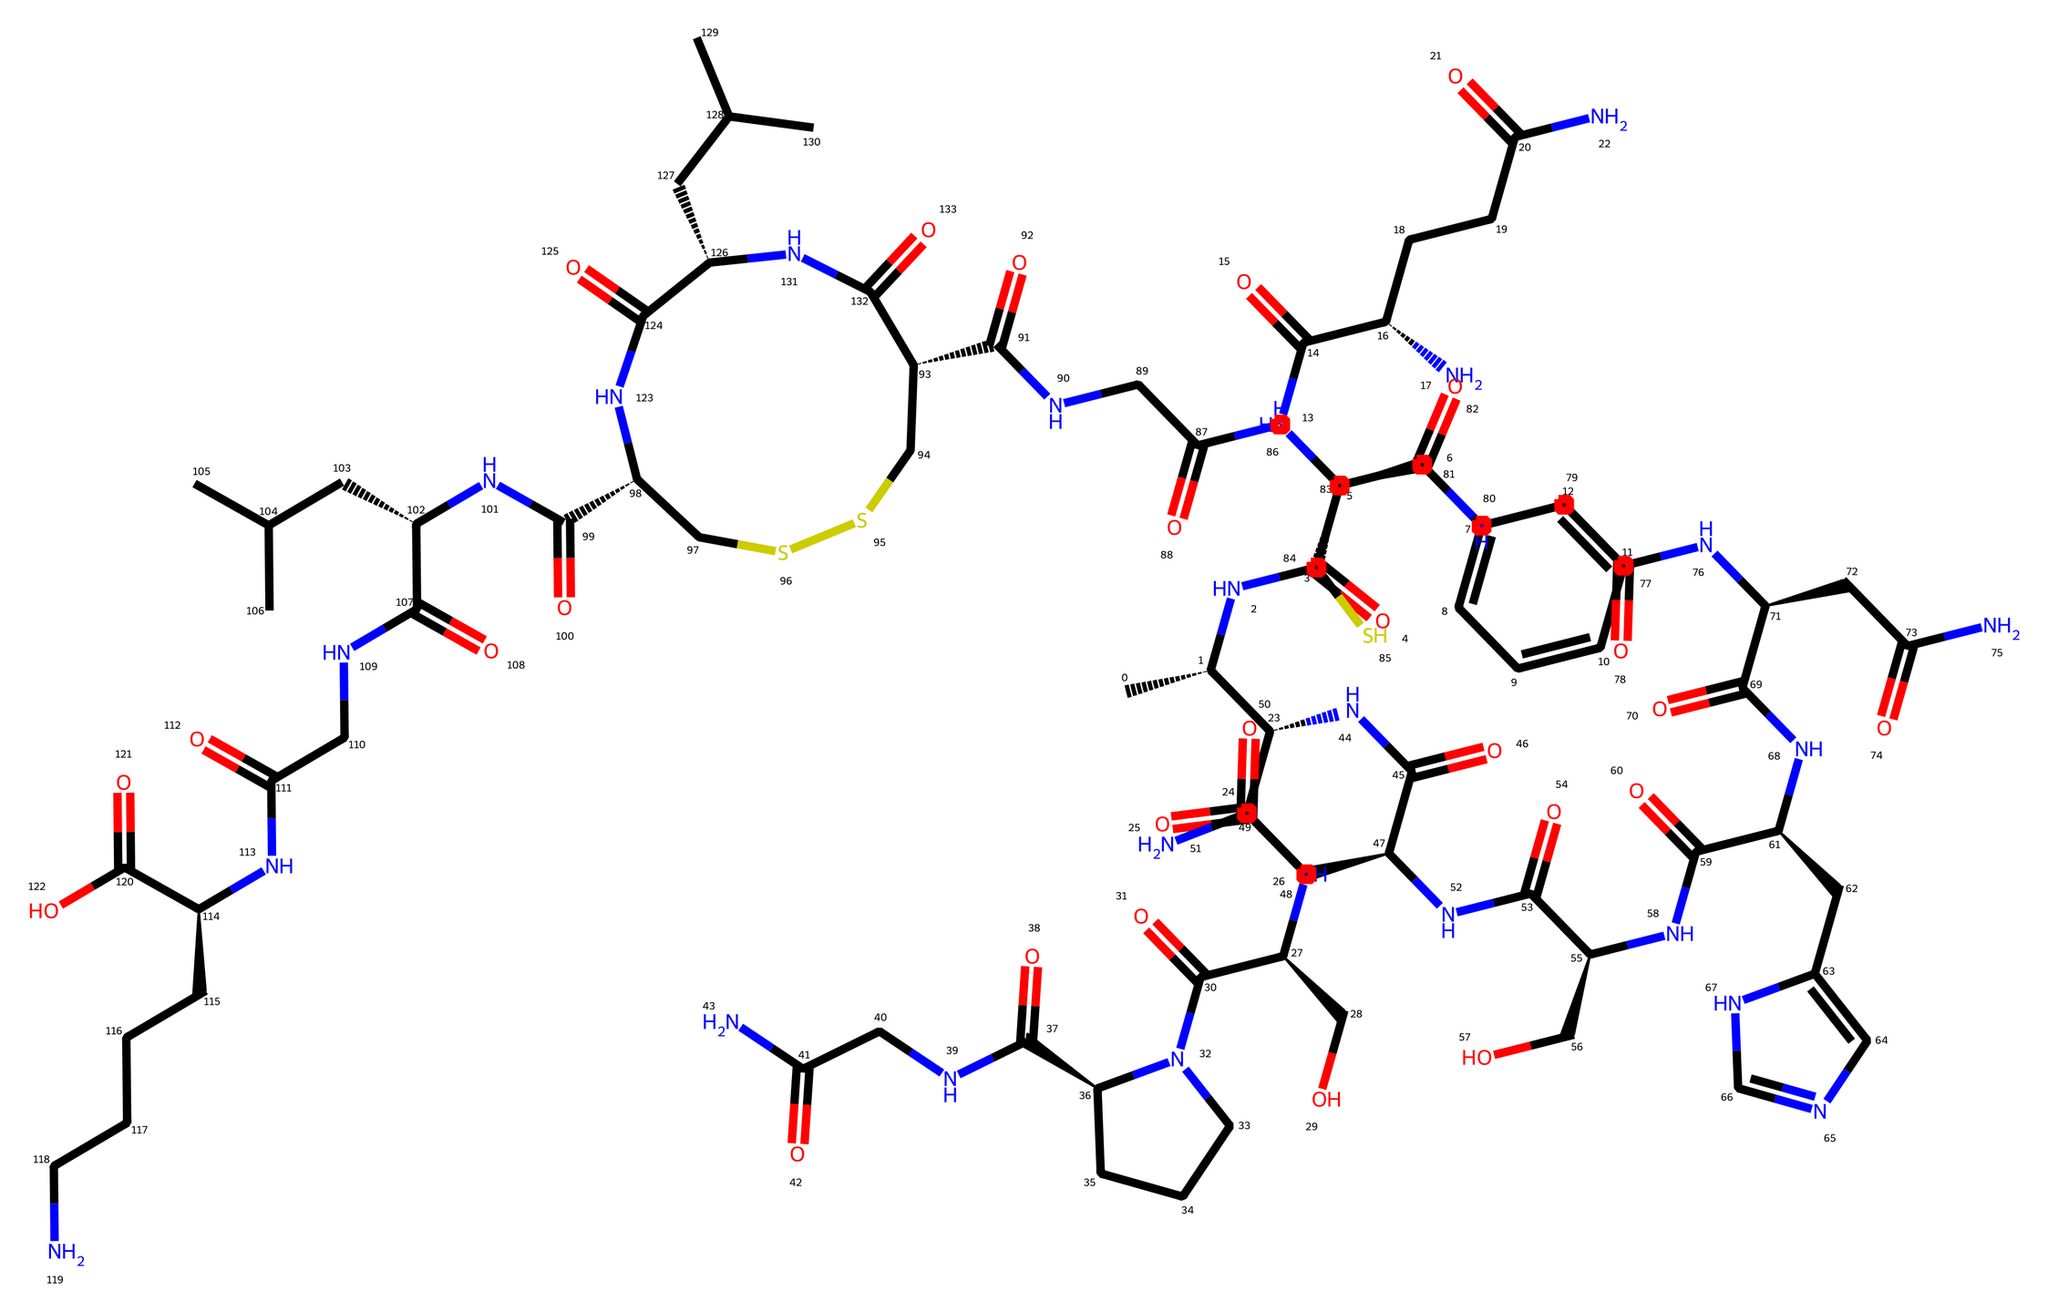What is the primary function of oxytocin in the body? Oxytocin is known for its role in social bonding, emotional connections, and community interactions, often referred to as the "love hormone."
Answer: social bonding How many nitrogen atoms are present in the structure? By analyzing the SMILES representation, there are seven instances of 'N', indicating seven nitrogen atoms in the chemical structure.
Answer: seven What type of chemical is represented by this SMILES notation? The structure includes peptide bonds and several amino acid sequences, which is characteristic of hormones, particularly peptide hormones like oxytocin.
Answer: peptide hormone What is the molecular weight approximately based on the structure? Calculating the molecular weight involves adding the weights of all atoms in the chemical structure; for oxytocin, it is approximately 1007 g/mol.
Answer: 1007 g/mol What functional groups are present in the oxytocin molecule? The molecule includes amides, a key feature of peptide hormones, and alcohol groups indicated by hydroxyl (-OH) sections complemented by the nitrogen atoms.
Answer: amides and alcohols How many cyclic structures are found in oxytocin? The structure contains two cyclic portions (rings) typically associated with peptide structures, particularly in the central part of the molecule.
Answer: two 